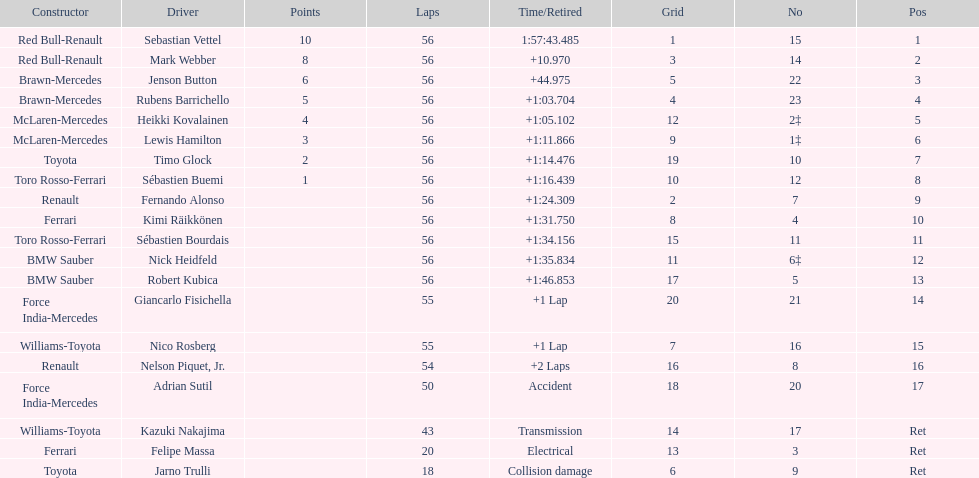Who are all of the drivers? Sebastian Vettel, Mark Webber, Jenson Button, Rubens Barrichello, Heikki Kovalainen, Lewis Hamilton, Timo Glock, Sébastien Buemi, Fernando Alonso, Kimi Räikkönen, Sébastien Bourdais, Nick Heidfeld, Robert Kubica, Giancarlo Fisichella, Nico Rosberg, Nelson Piquet, Jr., Adrian Sutil, Kazuki Nakajima, Felipe Massa, Jarno Trulli. Who were their constructors? Red Bull-Renault, Red Bull-Renault, Brawn-Mercedes, Brawn-Mercedes, McLaren-Mercedes, McLaren-Mercedes, Toyota, Toro Rosso-Ferrari, Renault, Ferrari, Toro Rosso-Ferrari, BMW Sauber, BMW Sauber, Force India-Mercedes, Williams-Toyota, Renault, Force India-Mercedes, Williams-Toyota, Ferrari, Toyota. Who was the first listed driver to not drive a ferrari?? Sebastian Vettel. 